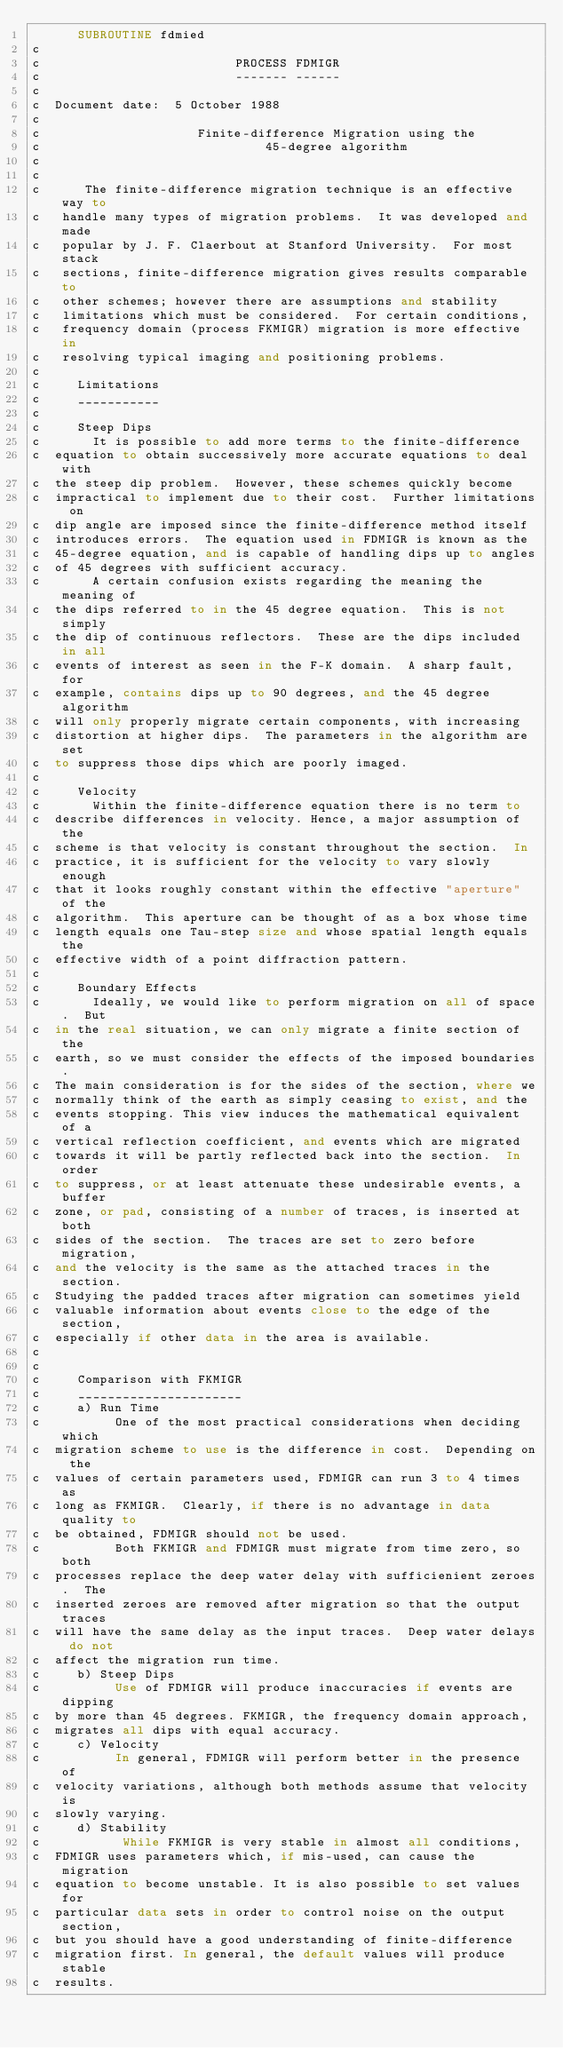<code> <loc_0><loc_0><loc_500><loc_500><_FORTRAN_>      SUBROUTINE fdmied
c
c                          PROCESS FDMIGR
c                          ------- ------
c
c  Document date:  5 October 1988
c
c                     Finite-difference Migration using the
c                              45-degree algorithm
c
c
c      The finite-difference migration technique is an effective way to
c   handle many types of migration problems.  It was developed and made
c   popular by J. F. Claerbout at Stanford University.  For most stack
c   sections, finite-difference migration gives results comparable to
c   other schemes; however there are assumptions and stability
c   limitations which must be considered.  For certain conditions,
c   frequency domain (process FKMIGR) migration is more effective in
c   resolving typical imaging and positioning problems.
c
c     Limitations
c     ___________
c
c     Steep Dips
c       It is possible to add more terms to the finite-difference
c  equation to obtain successively more accurate equations to deal with
c  the steep dip problem.  However, these schemes quickly become
c  impractical to implement due to their cost.  Further limitations on
c  dip angle are imposed since the finite-difference method itself
c  introduces errors.  The equation used in FDMIGR is known as the
c  45-degree equation, and is capable of handling dips up to angles
c  of 45 degrees with sufficient accuracy.
c       A certain confusion exists regarding the meaning the meaning of
c  the dips referred to in the 45 degree equation.  This is not simply
c  the dip of continuous reflectors.  These are the dips included in all
c  events of interest as seen in the F-K domain.  A sharp fault, for
c  example, contains dips up to 90 degrees, and the 45 degree algorithm
c  will only properly migrate certain components, with increasing
c  distortion at higher dips.  The parameters in the algorithm are set
c  to suppress those dips which are poorly imaged.
c
c     Velocity
c       Within the finite-difference equation there is no term to
c  describe differences in velocity. Hence, a major assumption of the
c  scheme is that velocity is constant throughout the section.  In
c  practice, it is sufficient for the velocity to vary slowly enough
c  that it looks roughly constant within the effective "aperture" of the
c  algorithm.  This aperture can be thought of as a box whose time
c  length equals one Tau-step size and whose spatial length equals the
c  effective width of a point diffraction pattern.
c
c     Boundary Effects
c       Ideally, we would like to perform migration on all of space.  But
c  in the real situation, we can only migrate a finite section of the
c  earth, so we must consider the effects of the imposed boundaries.
c  The main consideration is for the sides of the section, where we
c  normally think of the earth as simply ceasing to exist, and the
c  events stopping. This view induces the mathematical equivalent of a
c  vertical reflection coefficient, and events which are migrated
c  towards it will be partly reflected back into the section.  In order
c  to suppress, or at least attenuate these undesirable events, a buffer
c  zone, or pad, consisting of a number of traces, is inserted at both
c  sides of the section.  The traces are set to zero before migration,
c  and the velocity is the same as the attached traces in the section.
c  Studying the padded traces after migration can sometimes yield
c  valuable information about events close to the edge of the section,
c  especially if other data in the area is available.
c
c
c     Comparison with FKMIGR
c     ______________________
c     a) Run Time
c          One of the most practical considerations when deciding which
c  migration scheme to use is the difference in cost.  Depending on the
c  values of certain parameters used, FDMIGR can run 3 to 4 times as
c  long as FKMIGR.  Clearly, if there is no advantage in data quality to
c  be obtained, FDMIGR should not be used.
c          Both FKMIGR and FDMIGR must migrate from time zero, so both
c  processes replace the deep water delay with sufficienient zeroes.  The
c  inserted zeroes are removed after migration so that the output traces
c  will have the same delay as the input traces.  Deep water delays do not
c  affect the migration run time.
c     b) Steep Dips
c          Use of FDMIGR will produce inaccuracies if events are dipping
c  by more than 45 degrees. FKMIGR, the frequency domain approach,
c  migrates all dips with equal accuracy.
c     c) Velocity
c          In general, FDMIGR will perform better in the presence of
c  velocity variations, although both methods assume that velocity is
c  slowly varying.
c     d) Stability
c           While FKMIGR is very stable in almost all conditions,
c  FDMIGR uses parameters which, if mis-used, can cause the migration
c  equation to become unstable. It is also possible to set values for
c  particular data sets in order to control noise on the output section,
c  but you should have a good understanding of finite-difference
c  migration first. In general, the default values will produce stable
c  results.</code> 